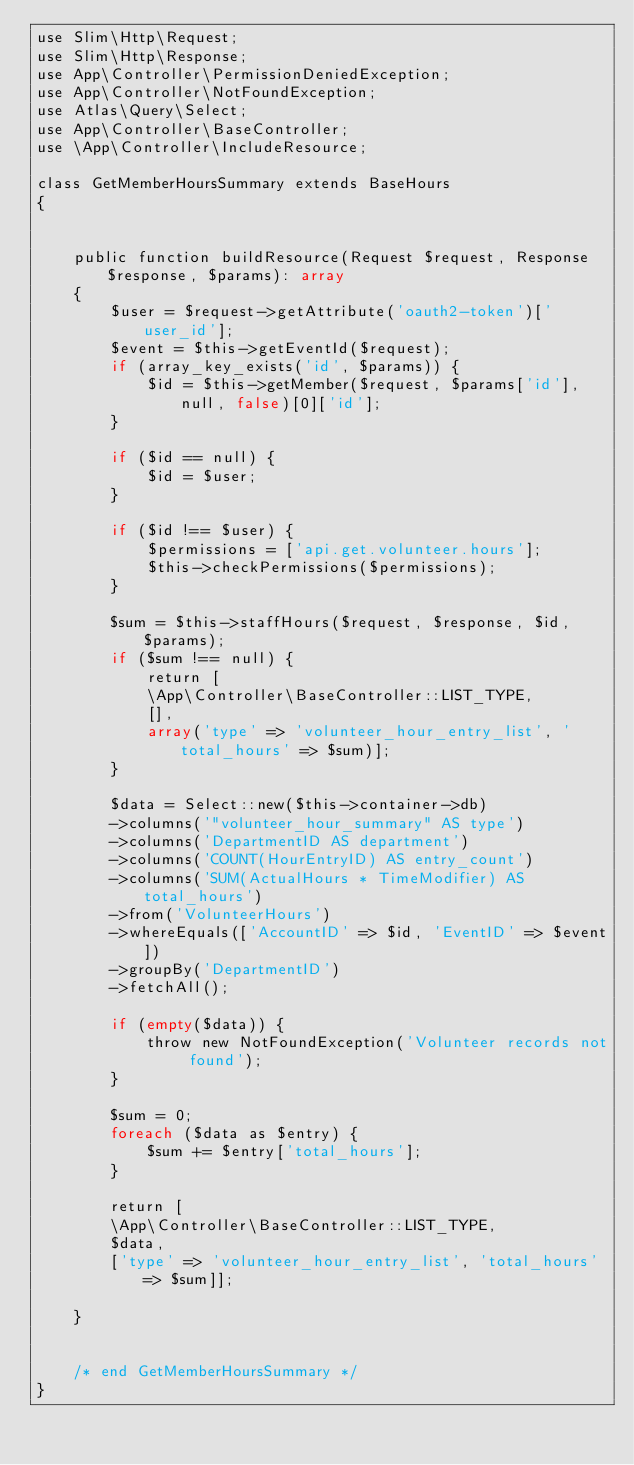<code> <loc_0><loc_0><loc_500><loc_500><_PHP_>use Slim\Http\Request;
use Slim\Http\Response;
use App\Controller\PermissionDeniedException;
use App\Controller\NotFoundException;
use Atlas\Query\Select;
use App\Controller\BaseController;
use \App\Controller\IncludeResource;

class GetMemberHoursSummary extends BaseHours
{


    public function buildResource(Request $request, Response $response, $params): array
    {
        $user = $request->getAttribute('oauth2-token')['user_id'];
        $event = $this->getEventId($request);
        if (array_key_exists('id', $params)) {
            $id = $this->getMember($request, $params['id'], null, false)[0]['id'];
        }

        if ($id == null) {
            $id = $user;
        }

        if ($id !== $user) {
            $permissions = ['api.get.volunteer.hours'];
            $this->checkPermissions($permissions);
        }

        $sum = $this->staffHours($request, $response, $id, $params);
        if ($sum !== null) {
            return [
            \App\Controller\BaseController::LIST_TYPE,
            [],
            array('type' => 'volunteer_hour_entry_list', 'total_hours' => $sum)];
        }

        $data = Select::new($this->container->db)
        ->columns('"volunteer_hour_summary" AS type')
        ->columns('DepartmentID AS department')
        ->columns('COUNT(HourEntryID) AS entry_count')
        ->columns('SUM(ActualHours * TimeModifier) AS total_hours')
        ->from('VolunteerHours')
        ->whereEquals(['AccountID' => $id, 'EventID' => $event])
        ->groupBy('DepartmentID')
        ->fetchAll();

        if (empty($data)) {
            throw new NotFoundException('Volunteer records not found');
        }

        $sum = 0;
        foreach ($data as $entry) {
            $sum += $entry['total_hours'];
        }

        return [
        \App\Controller\BaseController::LIST_TYPE,
        $data,
        ['type' => 'volunteer_hour_entry_list', 'total_hours' => $sum]];

    }


    /* end GetMemberHoursSummary */
}
</code> 